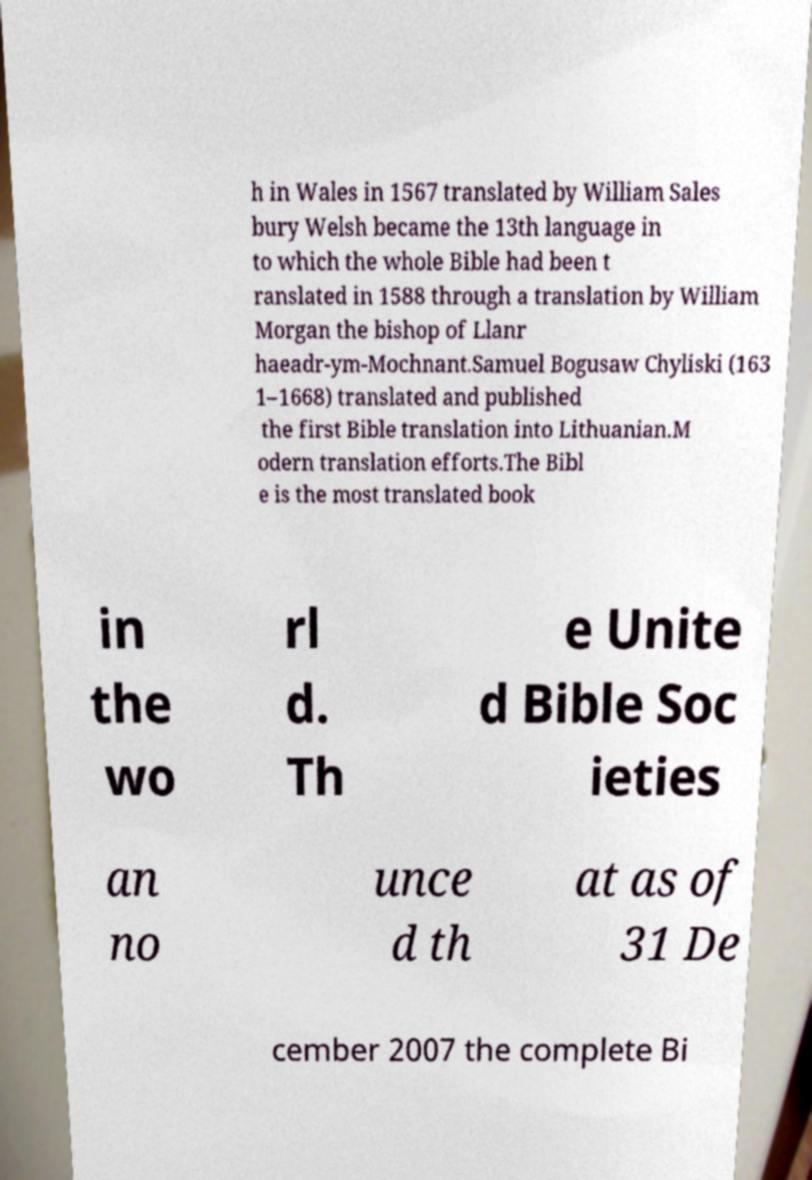For documentation purposes, I need the text within this image transcribed. Could you provide that? h in Wales in 1567 translated by William Sales bury Welsh became the 13th language in to which the whole Bible had been t ranslated in 1588 through a translation by William Morgan the bishop of Llanr haeadr-ym-Mochnant.Samuel Bogusaw Chyliski (163 1–1668) translated and published the first Bible translation into Lithuanian.M odern translation efforts.The Bibl e is the most translated book in the wo rl d. Th e Unite d Bible Soc ieties an no unce d th at as of 31 De cember 2007 the complete Bi 